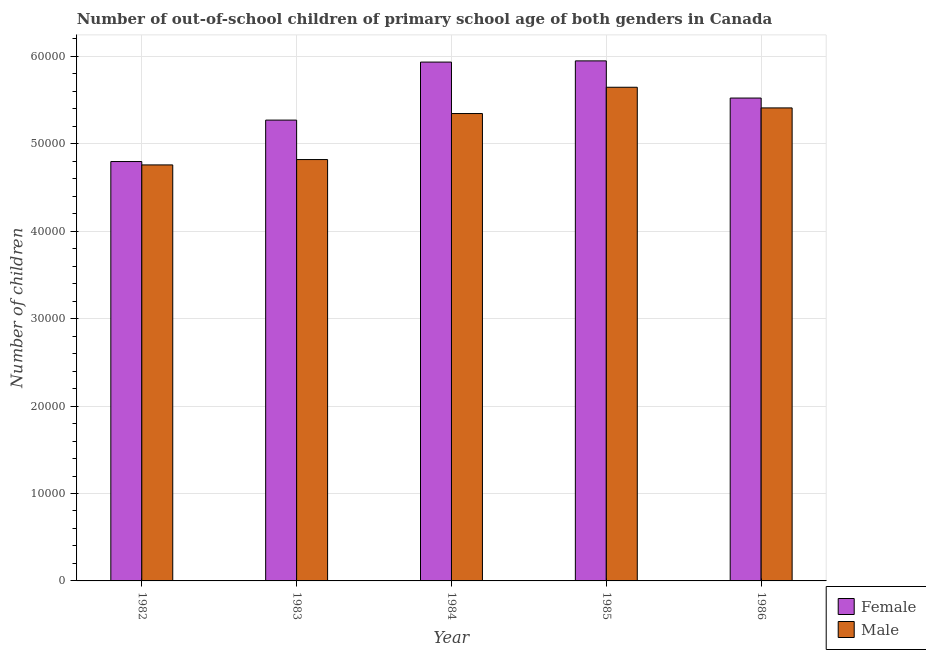Are the number of bars per tick equal to the number of legend labels?
Keep it short and to the point. Yes. In how many cases, is the number of bars for a given year not equal to the number of legend labels?
Your answer should be very brief. 0. What is the number of male out-of-school students in 1982?
Provide a succinct answer. 4.76e+04. Across all years, what is the maximum number of female out-of-school students?
Offer a very short reply. 5.95e+04. Across all years, what is the minimum number of male out-of-school students?
Your answer should be compact. 4.76e+04. In which year was the number of male out-of-school students maximum?
Make the answer very short. 1985. What is the total number of male out-of-school students in the graph?
Your answer should be very brief. 2.60e+05. What is the difference between the number of male out-of-school students in 1983 and that in 1984?
Keep it short and to the point. -5263. What is the difference between the number of female out-of-school students in 1986 and the number of male out-of-school students in 1984?
Your answer should be compact. -4113. What is the average number of male out-of-school students per year?
Ensure brevity in your answer.  5.20e+04. What is the ratio of the number of female out-of-school students in 1983 to that in 1985?
Give a very brief answer. 0.89. What is the difference between the highest and the second highest number of female out-of-school students?
Ensure brevity in your answer.  139. What is the difference between the highest and the lowest number of female out-of-school students?
Ensure brevity in your answer.  1.15e+04. In how many years, is the number of female out-of-school students greater than the average number of female out-of-school students taken over all years?
Your answer should be compact. 3. Is the sum of the number of male out-of-school students in 1983 and 1984 greater than the maximum number of female out-of-school students across all years?
Give a very brief answer. Yes. What does the 1st bar from the left in 1984 represents?
Provide a succinct answer. Female. What does the 2nd bar from the right in 1986 represents?
Offer a very short reply. Female. How many years are there in the graph?
Your answer should be very brief. 5. Are the values on the major ticks of Y-axis written in scientific E-notation?
Give a very brief answer. No. Does the graph contain any zero values?
Keep it short and to the point. No. Does the graph contain grids?
Provide a short and direct response. Yes. How are the legend labels stacked?
Your response must be concise. Vertical. What is the title of the graph?
Ensure brevity in your answer.  Number of out-of-school children of primary school age of both genders in Canada. Does "Time to import" appear as one of the legend labels in the graph?
Offer a very short reply. No. What is the label or title of the Y-axis?
Ensure brevity in your answer.  Number of children. What is the Number of children in Female in 1982?
Make the answer very short. 4.80e+04. What is the Number of children in Male in 1982?
Give a very brief answer. 4.76e+04. What is the Number of children in Female in 1983?
Offer a terse response. 5.27e+04. What is the Number of children in Male in 1983?
Make the answer very short. 4.82e+04. What is the Number of children in Female in 1984?
Keep it short and to the point. 5.93e+04. What is the Number of children in Male in 1984?
Your answer should be compact. 5.35e+04. What is the Number of children in Female in 1985?
Keep it short and to the point. 5.95e+04. What is the Number of children of Male in 1985?
Your answer should be compact. 5.65e+04. What is the Number of children of Female in 1986?
Provide a short and direct response. 5.52e+04. What is the Number of children in Male in 1986?
Keep it short and to the point. 5.41e+04. Across all years, what is the maximum Number of children in Female?
Offer a terse response. 5.95e+04. Across all years, what is the maximum Number of children in Male?
Offer a very short reply. 5.65e+04. Across all years, what is the minimum Number of children in Female?
Provide a short and direct response. 4.80e+04. Across all years, what is the minimum Number of children in Male?
Offer a very short reply. 4.76e+04. What is the total Number of children of Female in the graph?
Offer a terse response. 2.75e+05. What is the total Number of children of Male in the graph?
Keep it short and to the point. 2.60e+05. What is the difference between the Number of children of Female in 1982 and that in 1983?
Offer a terse response. -4740. What is the difference between the Number of children in Male in 1982 and that in 1983?
Ensure brevity in your answer.  -612. What is the difference between the Number of children of Female in 1982 and that in 1984?
Provide a short and direct response. -1.14e+04. What is the difference between the Number of children of Male in 1982 and that in 1984?
Keep it short and to the point. -5875. What is the difference between the Number of children of Female in 1982 and that in 1985?
Make the answer very short. -1.15e+04. What is the difference between the Number of children of Male in 1982 and that in 1985?
Provide a succinct answer. -8882. What is the difference between the Number of children in Female in 1982 and that in 1986?
Provide a succinct answer. -7262. What is the difference between the Number of children in Male in 1982 and that in 1986?
Offer a terse response. -6519. What is the difference between the Number of children in Female in 1983 and that in 1984?
Keep it short and to the point. -6635. What is the difference between the Number of children in Male in 1983 and that in 1984?
Your response must be concise. -5263. What is the difference between the Number of children of Female in 1983 and that in 1985?
Keep it short and to the point. -6774. What is the difference between the Number of children of Male in 1983 and that in 1985?
Give a very brief answer. -8270. What is the difference between the Number of children of Female in 1983 and that in 1986?
Make the answer very short. -2522. What is the difference between the Number of children of Male in 1983 and that in 1986?
Offer a very short reply. -5907. What is the difference between the Number of children of Female in 1984 and that in 1985?
Ensure brevity in your answer.  -139. What is the difference between the Number of children in Male in 1984 and that in 1985?
Provide a succinct answer. -3007. What is the difference between the Number of children in Female in 1984 and that in 1986?
Your response must be concise. 4113. What is the difference between the Number of children in Male in 1984 and that in 1986?
Give a very brief answer. -644. What is the difference between the Number of children in Female in 1985 and that in 1986?
Offer a very short reply. 4252. What is the difference between the Number of children in Male in 1985 and that in 1986?
Provide a succinct answer. 2363. What is the difference between the Number of children in Female in 1982 and the Number of children in Male in 1983?
Offer a very short reply. -227. What is the difference between the Number of children in Female in 1982 and the Number of children in Male in 1984?
Ensure brevity in your answer.  -5490. What is the difference between the Number of children of Female in 1982 and the Number of children of Male in 1985?
Ensure brevity in your answer.  -8497. What is the difference between the Number of children of Female in 1982 and the Number of children of Male in 1986?
Offer a terse response. -6134. What is the difference between the Number of children of Female in 1983 and the Number of children of Male in 1984?
Offer a very short reply. -750. What is the difference between the Number of children in Female in 1983 and the Number of children in Male in 1985?
Offer a terse response. -3757. What is the difference between the Number of children of Female in 1983 and the Number of children of Male in 1986?
Ensure brevity in your answer.  -1394. What is the difference between the Number of children of Female in 1984 and the Number of children of Male in 1985?
Offer a very short reply. 2878. What is the difference between the Number of children in Female in 1984 and the Number of children in Male in 1986?
Offer a terse response. 5241. What is the difference between the Number of children in Female in 1985 and the Number of children in Male in 1986?
Give a very brief answer. 5380. What is the average Number of children of Female per year?
Keep it short and to the point. 5.49e+04. What is the average Number of children in Male per year?
Keep it short and to the point. 5.20e+04. In the year 1982, what is the difference between the Number of children of Female and Number of children of Male?
Your answer should be compact. 385. In the year 1983, what is the difference between the Number of children of Female and Number of children of Male?
Keep it short and to the point. 4513. In the year 1984, what is the difference between the Number of children in Female and Number of children in Male?
Your response must be concise. 5885. In the year 1985, what is the difference between the Number of children of Female and Number of children of Male?
Your answer should be very brief. 3017. In the year 1986, what is the difference between the Number of children of Female and Number of children of Male?
Your response must be concise. 1128. What is the ratio of the Number of children of Female in 1982 to that in 1983?
Your answer should be very brief. 0.91. What is the ratio of the Number of children of Male in 1982 to that in 1983?
Provide a short and direct response. 0.99. What is the ratio of the Number of children in Female in 1982 to that in 1984?
Your answer should be compact. 0.81. What is the ratio of the Number of children of Male in 1982 to that in 1984?
Keep it short and to the point. 0.89. What is the ratio of the Number of children of Female in 1982 to that in 1985?
Keep it short and to the point. 0.81. What is the ratio of the Number of children in Male in 1982 to that in 1985?
Your response must be concise. 0.84. What is the ratio of the Number of children of Female in 1982 to that in 1986?
Make the answer very short. 0.87. What is the ratio of the Number of children of Male in 1982 to that in 1986?
Provide a succinct answer. 0.88. What is the ratio of the Number of children in Female in 1983 to that in 1984?
Provide a short and direct response. 0.89. What is the ratio of the Number of children in Male in 1983 to that in 1984?
Your response must be concise. 0.9. What is the ratio of the Number of children in Female in 1983 to that in 1985?
Keep it short and to the point. 0.89. What is the ratio of the Number of children in Male in 1983 to that in 1985?
Give a very brief answer. 0.85. What is the ratio of the Number of children of Female in 1983 to that in 1986?
Make the answer very short. 0.95. What is the ratio of the Number of children of Male in 1983 to that in 1986?
Give a very brief answer. 0.89. What is the ratio of the Number of children of Female in 1984 to that in 1985?
Provide a short and direct response. 1. What is the ratio of the Number of children in Male in 1984 to that in 1985?
Keep it short and to the point. 0.95. What is the ratio of the Number of children of Female in 1984 to that in 1986?
Your answer should be very brief. 1.07. What is the ratio of the Number of children in Male in 1984 to that in 1986?
Ensure brevity in your answer.  0.99. What is the ratio of the Number of children in Female in 1985 to that in 1986?
Offer a very short reply. 1.08. What is the ratio of the Number of children of Male in 1985 to that in 1986?
Your answer should be very brief. 1.04. What is the difference between the highest and the second highest Number of children in Female?
Give a very brief answer. 139. What is the difference between the highest and the second highest Number of children in Male?
Give a very brief answer. 2363. What is the difference between the highest and the lowest Number of children of Female?
Keep it short and to the point. 1.15e+04. What is the difference between the highest and the lowest Number of children of Male?
Provide a succinct answer. 8882. 